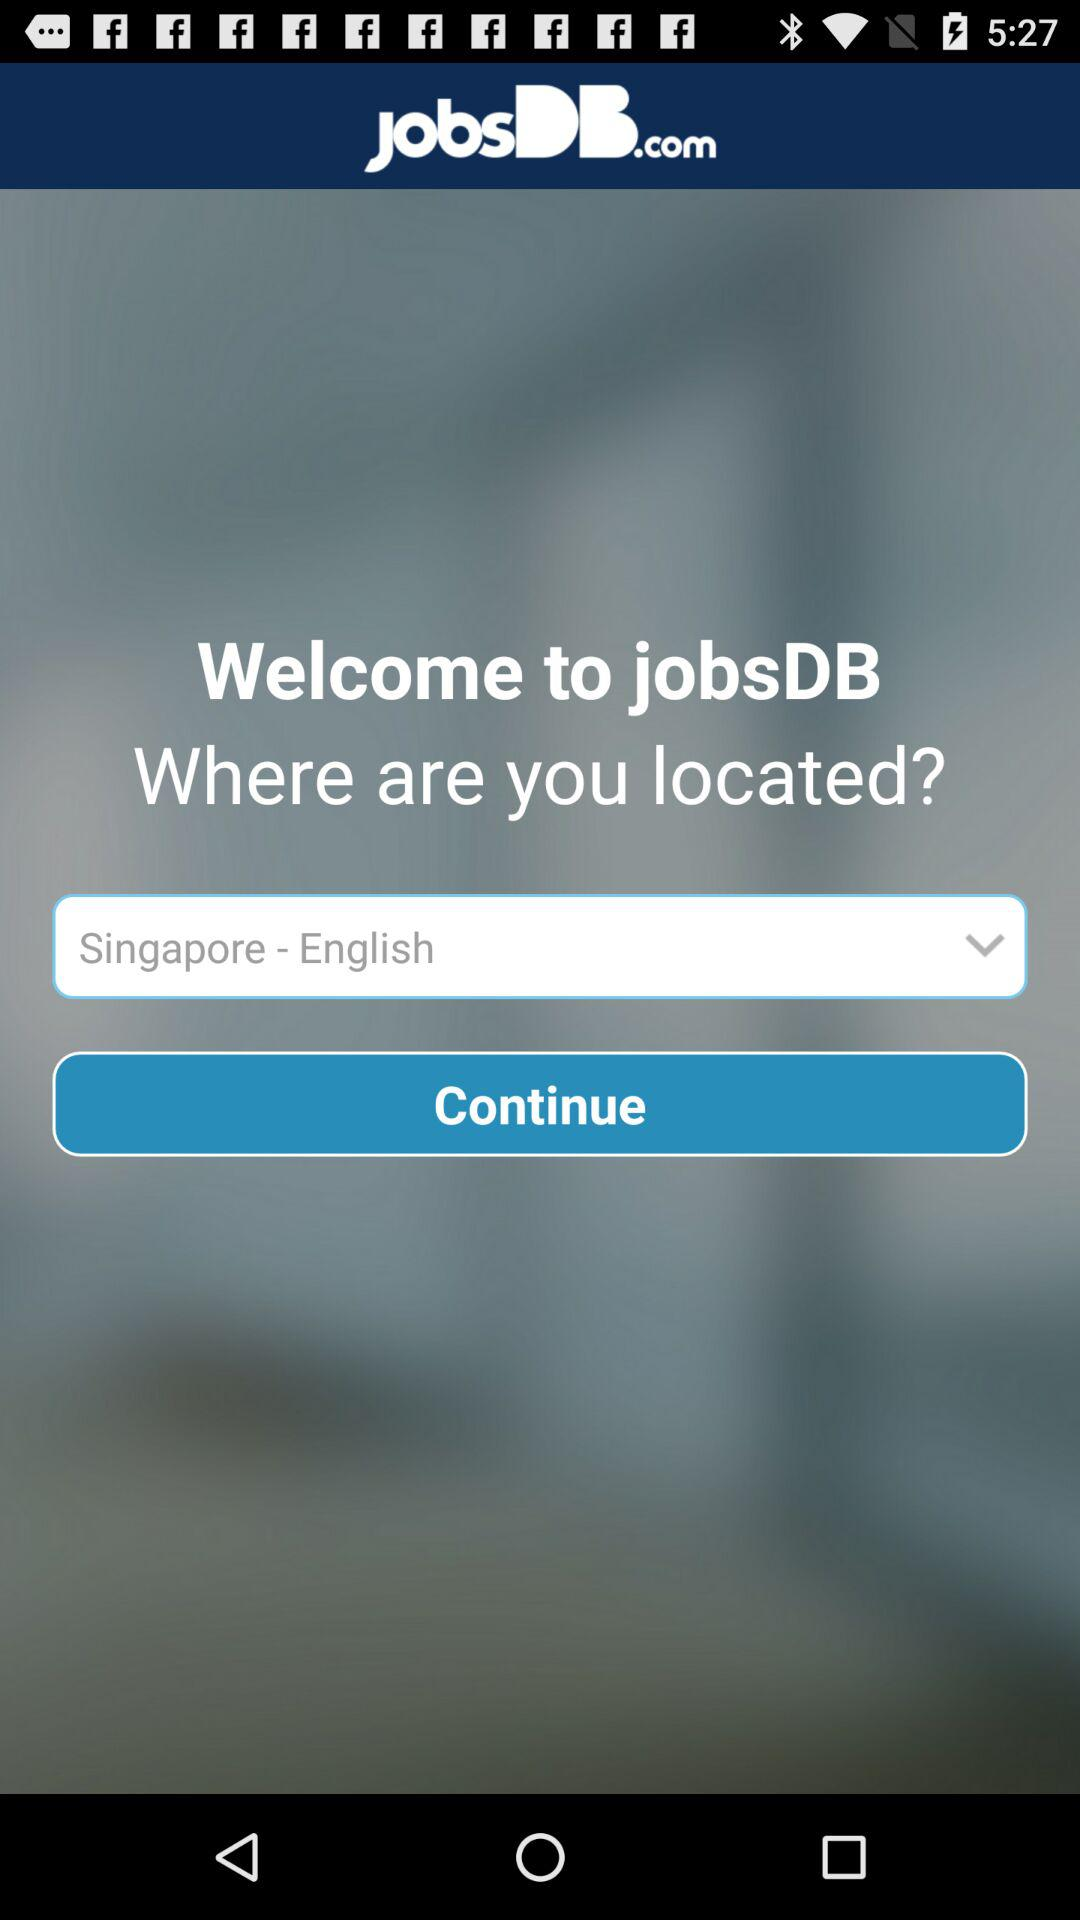What is the application name? The application name is "jobsDB". 